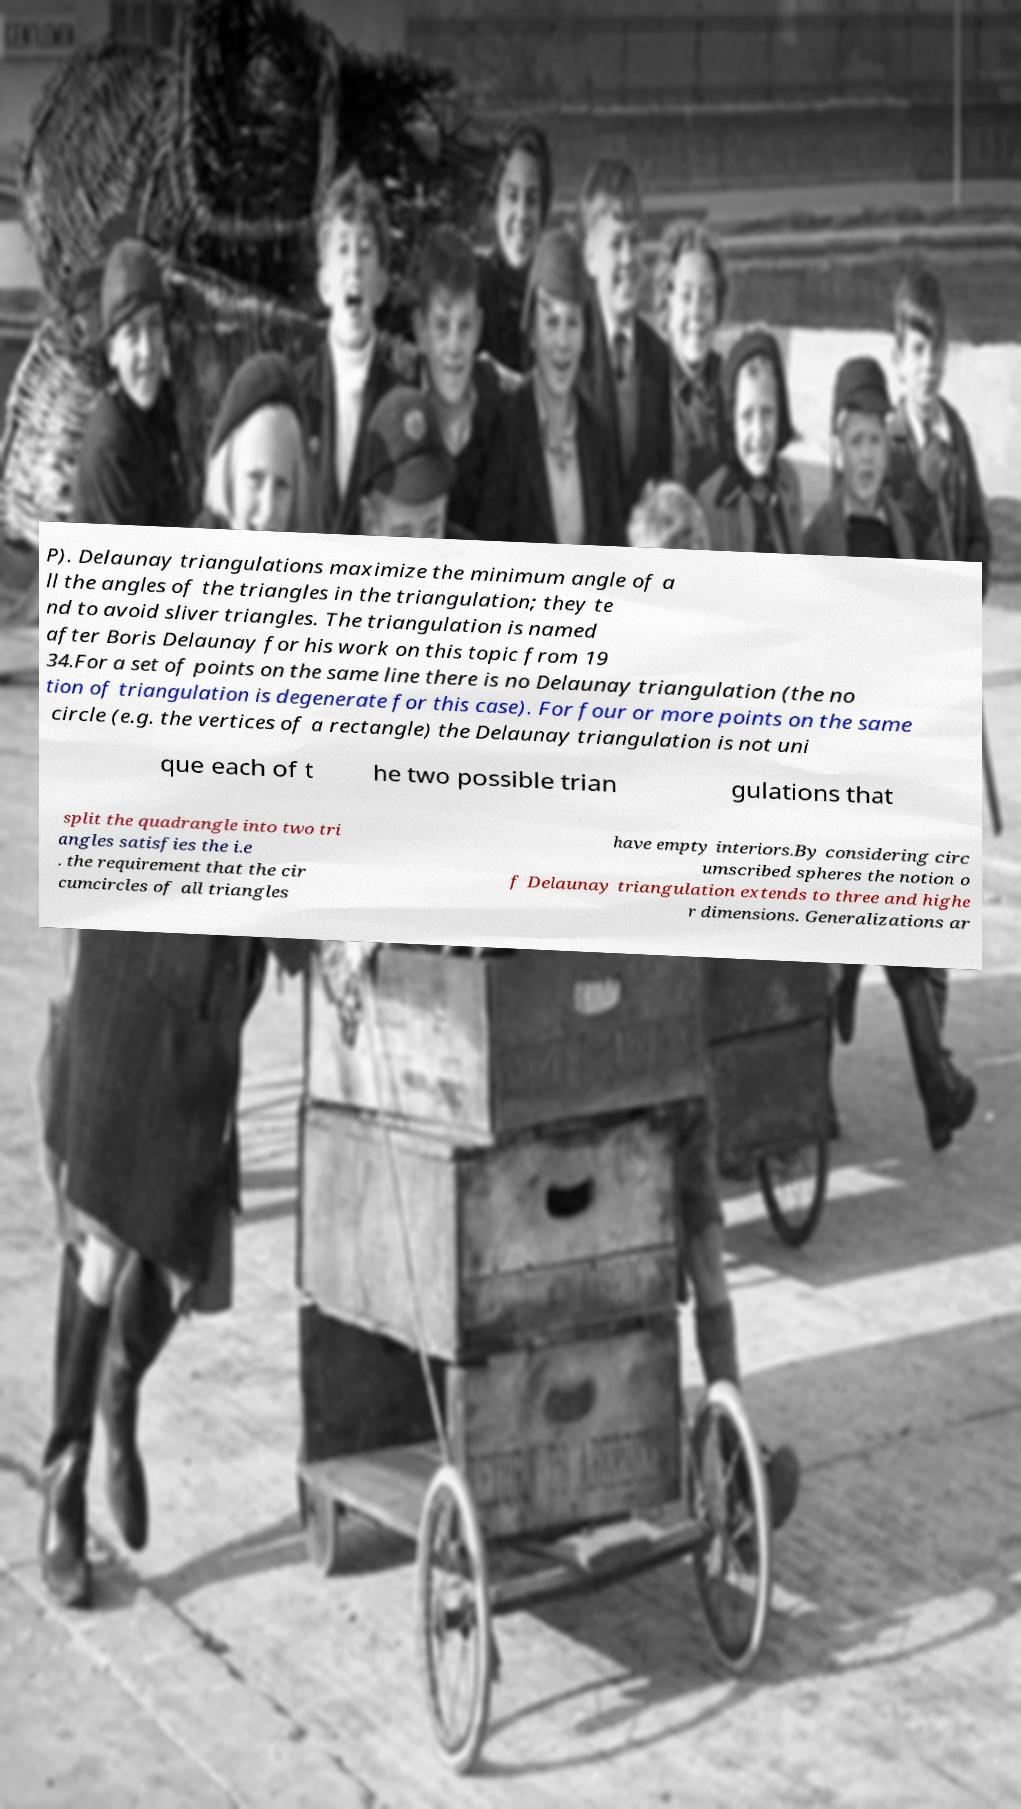I need the written content from this picture converted into text. Can you do that? P). Delaunay triangulations maximize the minimum angle of a ll the angles of the triangles in the triangulation; they te nd to avoid sliver triangles. The triangulation is named after Boris Delaunay for his work on this topic from 19 34.For a set of points on the same line there is no Delaunay triangulation (the no tion of triangulation is degenerate for this case). For four or more points on the same circle (e.g. the vertices of a rectangle) the Delaunay triangulation is not uni que each of t he two possible trian gulations that split the quadrangle into two tri angles satisfies the i.e . the requirement that the cir cumcircles of all triangles have empty interiors.By considering circ umscribed spheres the notion o f Delaunay triangulation extends to three and highe r dimensions. Generalizations ar 